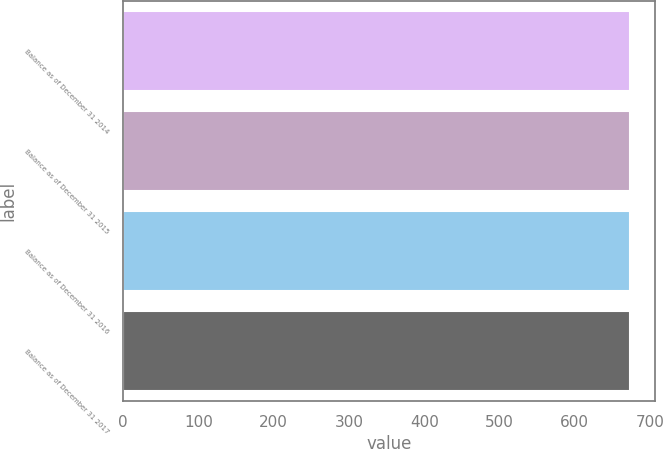Convert chart to OTSL. <chart><loc_0><loc_0><loc_500><loc_500><bar_chart><fcel>Balance as of December 31 2014<fcel>Balance as of December 31 2015<fcel>Balance as of December 31 2016<fcel>Balance as of December 31 2017<nl><fcel>673<fcel>673.1<fcel>673.2<fcel>673.3<nl></chart> 